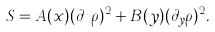<formula> <loc_0><loc_0><loc_500><loc_500>S = A ( x ) ( \partial _ { x } \rho ) ^ { 2 } + B ( y ) ( \partial _ { y } \rho ) ^ { 2 } .</formula> 